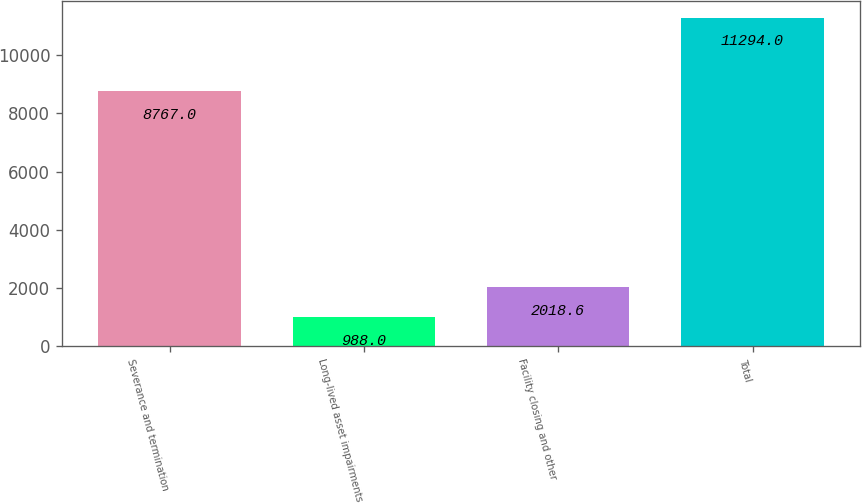Convert chart. <chart><loc_0><loc_0><loc_500><loc_500><bar_chart><fcel>Severance and termination<fcel>Long-lived asset impairments<fcel>Facility closing and other<fcel>Total<nl><fcel>8767<fcel>988<fcel>2018.6<fcel>11294<nl></chart> 